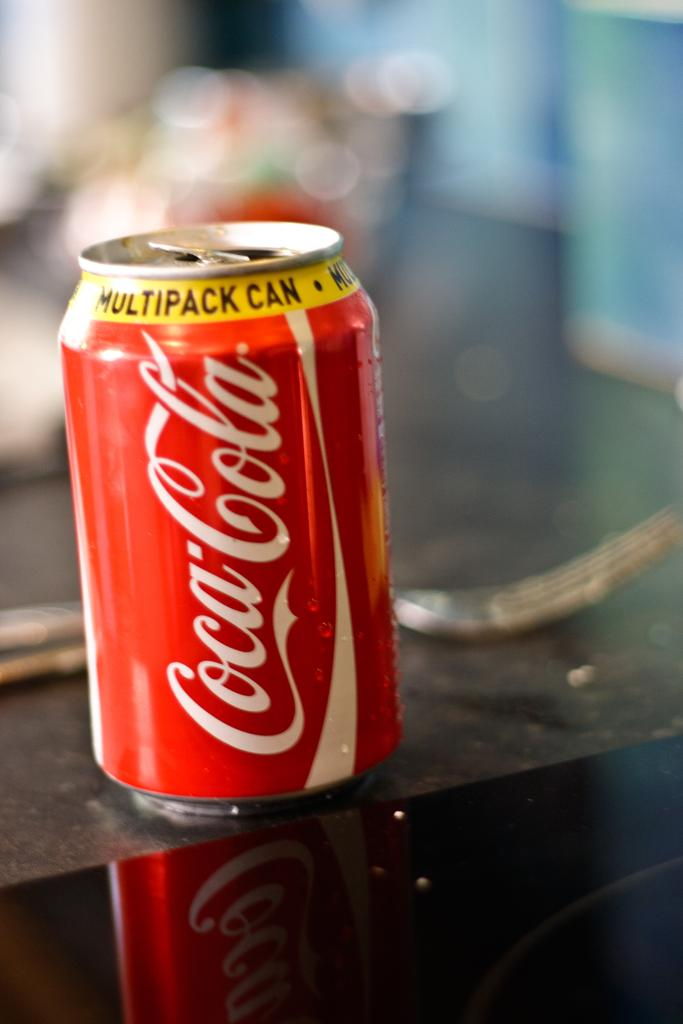What type of beverage container is in the image? There is a coke can in the image. Where is the coke can located? The coke can is on a table. What object is placed on the coke can? There is a fork on the coke can. Can you describe the background of the image? The background of the image is blurry. What type of education can be seen in the image? There is no reference to education in the image; it features a coke can with a fork on it and a blurry background. 